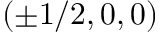<formula> <loc_0><loc_0><loc_500><loc_500>( \pm 1 / 2 , 0 , 0 )</formula> 